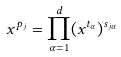Convert formula to latex. <formula><loc_0><loc_0><loc_500><loc_500>x ^ { p _ { j } } = \prod _ { \alpha = 1 } ^ { d } ( x ^ { t _ { \alpha } } ) ^ { s _ { j \alpha } }</formula> 